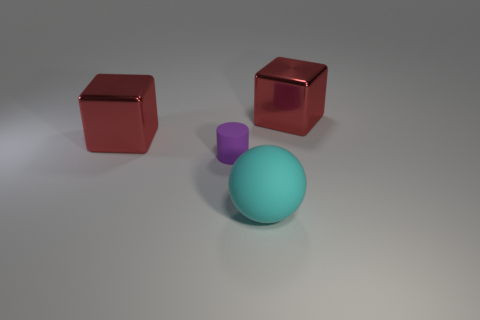Can you describe the texture and possible uses of the rubber objects in the image? The rubber objects appear to have a matte surface, indicating a non-reflective texture which is typical of rubber items. They could possibly be used as erasers, desk toys for stress relief, or educational tools for teaching geometry due to their distinct shapes. 